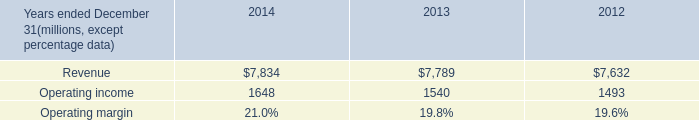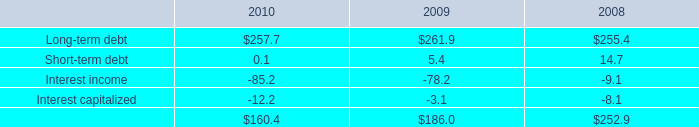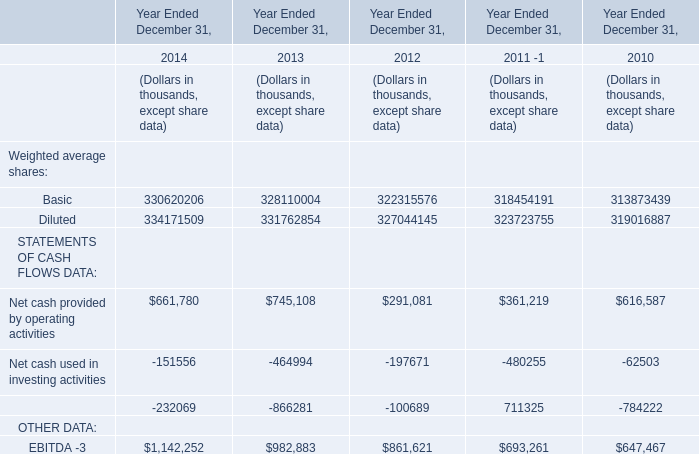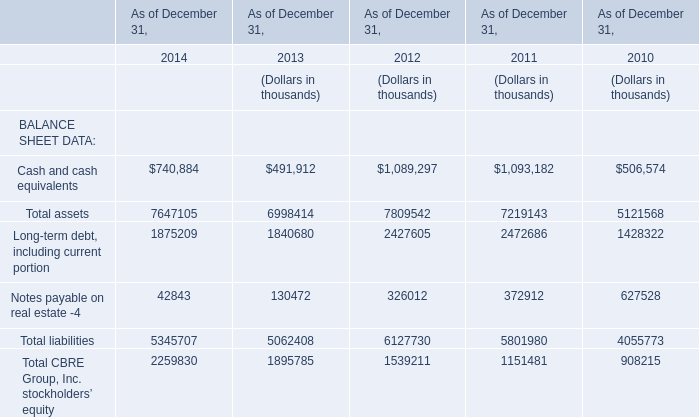What is the average value of Diluted for Weighted average shares and Total assets for BALANCE SHEET DATA in 2012? (in thousand) 
Computations: ((327044145 + 7809542) / 2)
Answer: 167426843.5. 